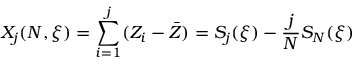Convert formula to latex. <formula><loc_0><loc_0><loc_500><loc_500>X _ { j } ( N , \xi ) = \sum _ { i = 1 } ^ { j } ( Z _ { i } - \bar { Z } ) = S _ { j } ( \xi ) - \frac { j } { N } S _ { N } ( \xi )</formula> 